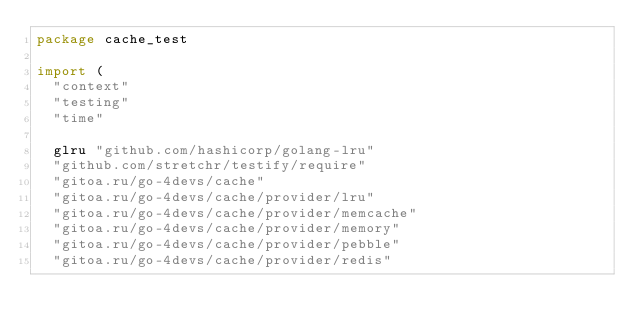<code> <loc_0><loc_0><loc_500><loc_500><_Go_>package cache_test

import (
	"context"
	"testing"
	"time"

	glru "github.com/hashicorp/golang-lru"
	"github.com/stretchr/testify/require"
	"gitoa.ru/go-4devs/cache"
	"gitoa.ru/go-4devs/cache/provider/lru"
	"gitoa.ru/go-4devs/cache/provider/memcache"
	"gitoa.ru/go-4devs/cache/provider/memory"
	"gitoa.ru/go-4devs/cache/provider/pebble"
	"gitoa.ru/go-4devs/cache/provider/redis"</code> 